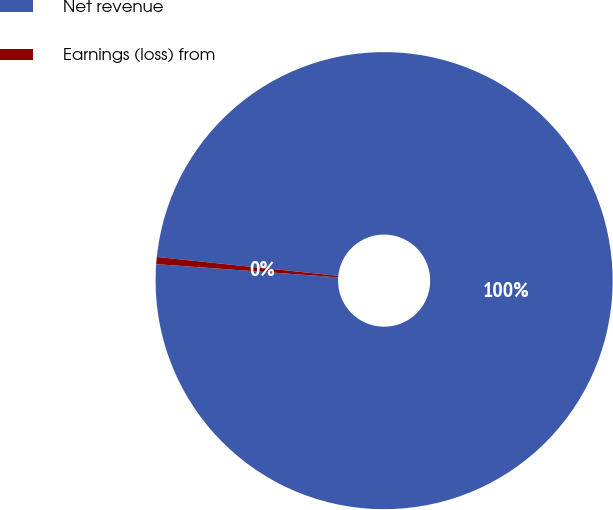Convert chart to OTSL. <chart><loc_0><loc_0><loc_500><loc_500><pie_chart><fcel>Net revenue<fcel>Earnings (loss) from<nl><fcel>99.5%<fcel>0.5%<nl></chart> 